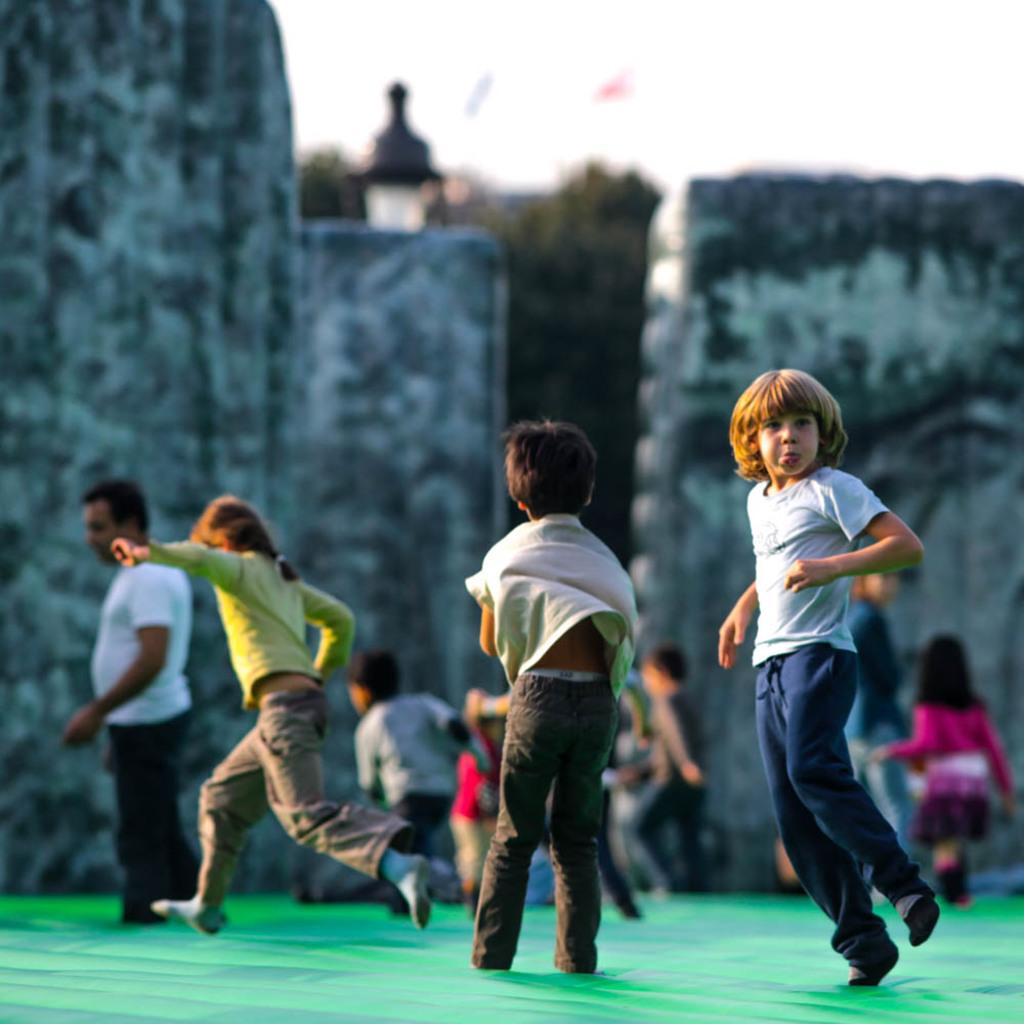How many people are in the image? There is a group of people in the image, but the exact number cannot be determined from the provided facts. What type of structures are present in the image? There are walls in the image. What type of vegetation is present in the image? There are trees in the image. What can be seen in the background of the image? The sky is visible in the background of the image. Can you see any blood on the walls in the image? There is no mention of blood in the image, so it cannot be determined if it is present or not. What type of rail is visible in the image? There is no rail present in the image. 